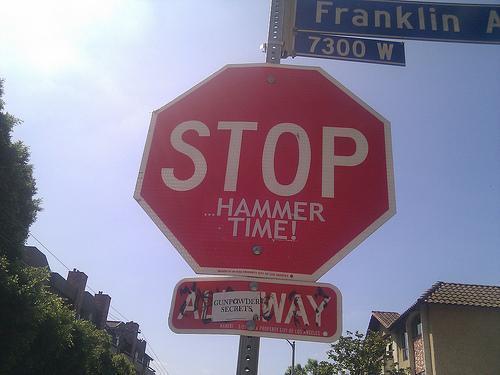How many signs are visible?
Give a very brief answer. 4. 